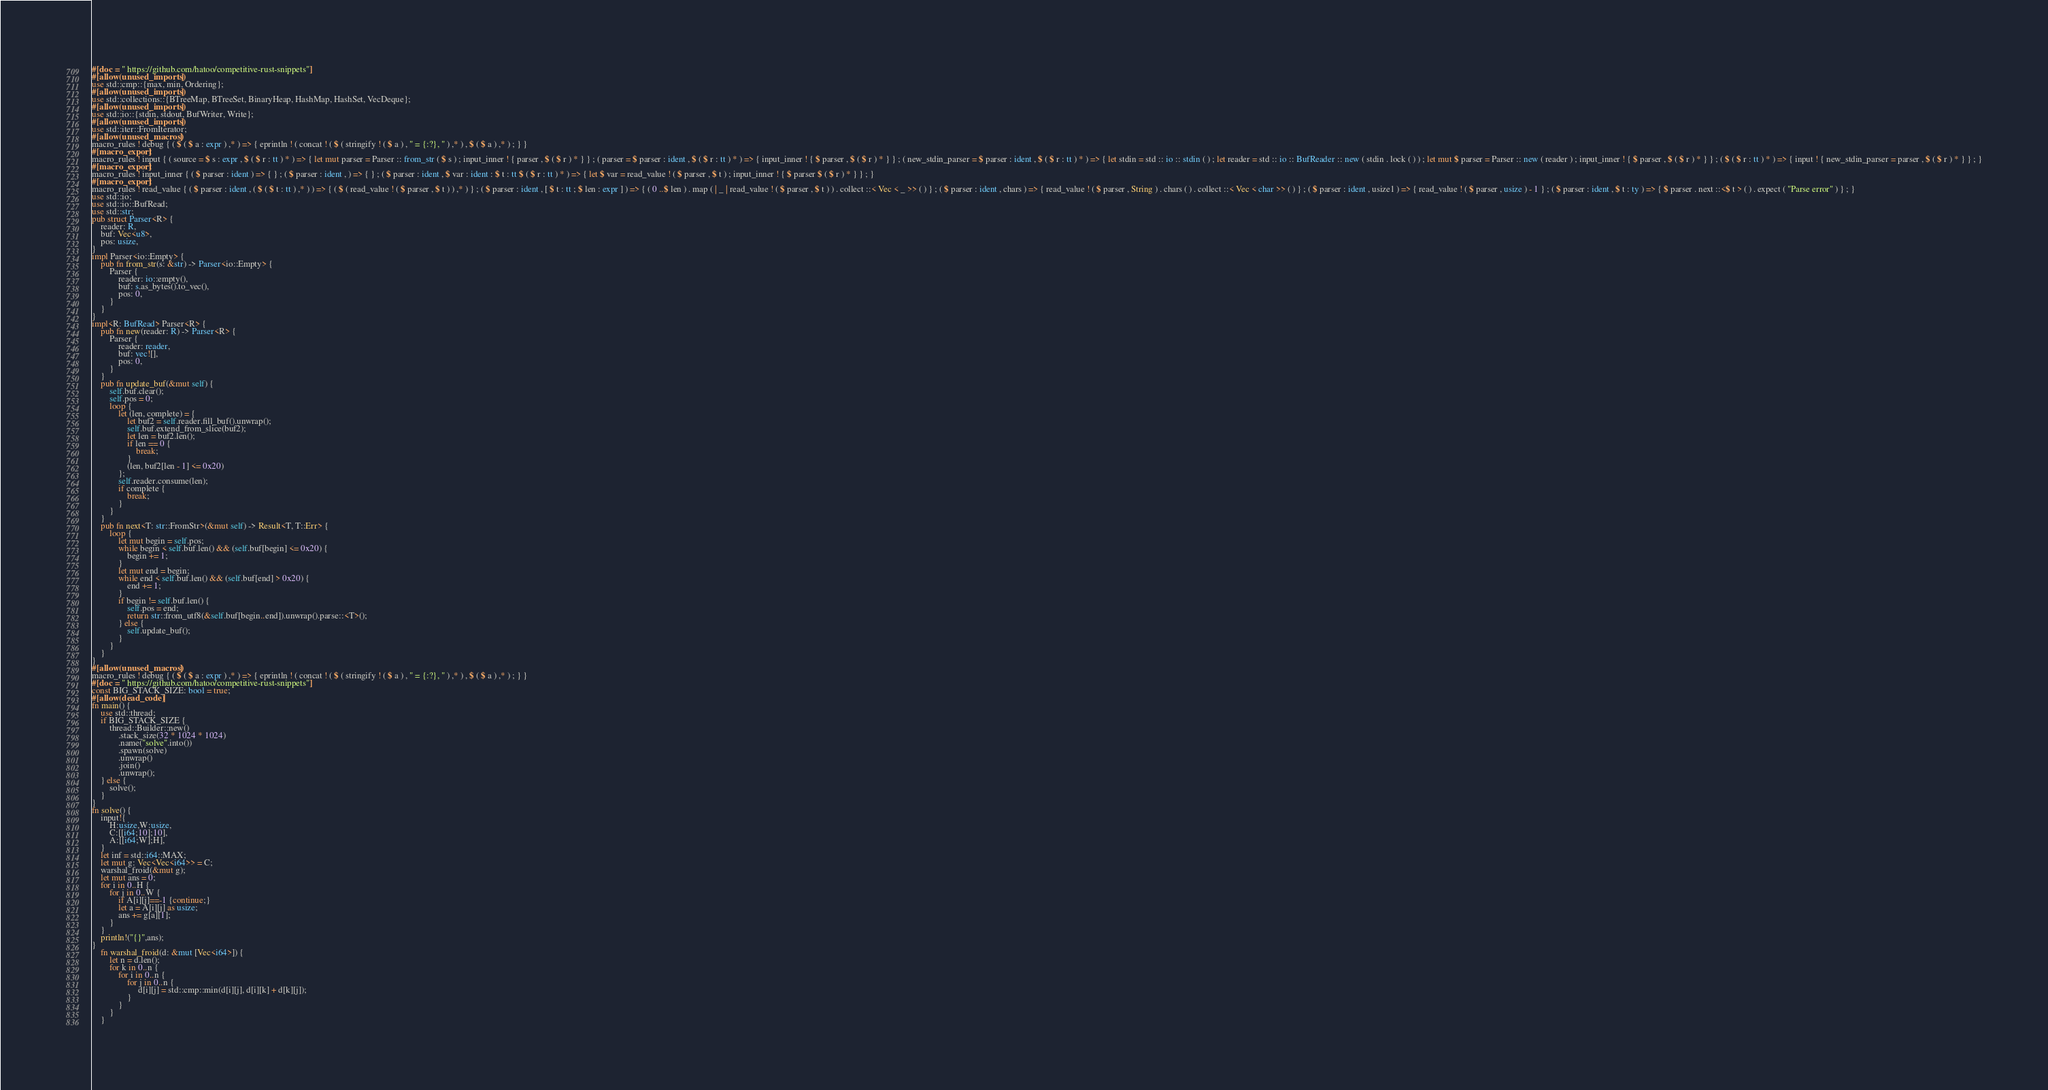<code> <loc_0><loc_0><loc_500><loc_500><_Rust_>#[doc = " https://github.com/hatoo/competitive-rust-snippets"]
#[allow(unused_imports)]
use std::cmp::{max, min, Ordering};
#[allow(unused_imports)]
use std::collections::{BTreeMap, BTreeSet, BinaryHeap, HashMap, HashSet, VecDeque};
#[allow(unused_imports)]
use std::io::{stdin, stdout, BufWriter, Write};
#[allow(unused_imports)]
use std::iter::FromIterator;
#[allow(unused_macros)]
macro_rules ! debug { ( $ ( $ a : expr ) ,* ) => { eprintln ! ( concat ! ( $ ( stringify ! ( $ a ) , " = {:?}, " ) ,* ) , $ ( $ a ) ,* ) ; } }
#[macro_export]
macro_rules ! input { ( source = $ s : expr , $ ( $ r : tt ) * ) => { let mut parser = Parser :: from_str ( $ s ) ; input_inner ! { parser , $ ( $ r ) * } } ; ( parser = $ parser : ident , $ ( $ r : tt ) * ) => { input_inner ! { $ parser , $ ( $ r ) * } } ; ( new_stdin_parser = $ parser : ident , $ ( $ r : tt ) * ) => { let stdin = std :: io :: stdin ( ) ; let reader = std :: io :: BufReader :: new ( stdin . lock ( ) ) ; let mut $ parser = Parser :: new ( reader ) ; input_inner ! { $ parser , $ ( $ r ) * } } ; ( $ ( $ r : tt ) * ) => { input ! { new_stdin_parser = parser , $ ( $ r ) * } } ; }
#[macro_export]
macro_rules ! input_inner { ( $ parser : ident ) => { } ; ( $ parser : ident , ) => { } ; ( $ parser : ident , $ var : ident : $ t : tt $ ( $ r : tt ) * ) => { let $ var = read_value ! ( $ parser , $ t ) ; input_inner ! { $ parser $ ( $ r ) * } } ; }
#[macro_export]
macro_rules ! read_value { ( $ parser : ident , ( $ ( $ t : tt ) ,* ) ) => { ( $ ( read_value ! ( $ parser , $ t ) ) ,* ) } ; ( $ parser : ident , [ $ t : tt ; $ len : expr ] ) => { ( 0 ..$ len ) . map ( | _ | read_value ! ( $ parser , $ t ) ) . collect ::< Vec < _ >> ( ) } ; ( $ parser : ident , chars ) => { read_value ! ( $ parser , String ) . chars ( ) . collect ::< Vec < char >> ( ) } ; ( $ parser : ident , usize1 ) => { read_value ! ( $ parser , usize ) - 1 } ; ( $ parser : ident , $ t : ty ) => { $ parser . next ::<$ t > ( ) . expect ( "Parse error" ) } ; }
use std::io;
use std::io::BufRead;
use std::str;
pub struct Parser<R> {
    reader: R,
    buf: Vec<u8>,
    pos: usize,
}
impl Parser<io::Empty> {
    pub fn from_str(s: &str) -> Parser<io::Empty> {
        Parser {
            reader: io::empty(),
            buf: s.as_bytes().to_vec(),
            pos: 0,
        }
    }
}
impl<R: BufRead> Parser<R> {
    pub fn new(reader: R) -> Parser<R> {
        Parser {
            reader: reader,
            buf: vec![],
            pos: 0,
        }
    }
    pub fn update_buf(&mut self) {
        self.buf.clear();
        self.pos = 0;
        loop {
            let (len, complete) = {
                let buf2 = self.reader.fill_buf().unwrap();
                self.buf.extend_from_slice(buf2);
                let len = buf2.len();
                if len == 0 {
                    break;
                }
                (len, buf2[len - 1] <= 0x20)
            };
            self.reader.consume(len);
            if complete {
                break;
            }
        }
    }
    pub fn next<T: str::FromStr>(&mut self) -> Result<T, T::Err> {
        loop {
            let mut begin = self.pos;
            while begin < self.buf.len() && (self.buf[begin] <= 0x20) {
                begin += 1;
            }
            let mut end = begin;
            while end < self.buf.len() && (self.buf[end] > 0x20) {
                end += 1;
            }
            if begin != self.buf.len() {
                self.pos = end;
                return str::from_utf8(&self.buf[begin..end]).unwrap().parse::<T>();
            } else {
                self.update_buf();
            }
        }
    }
}
#[allow(unused_macros)]
macro_rules ! debug { ( $ ( $ a : expr ) ,* ) => { eprintln ! ( concat ! ( $ ( stringify ! ( $ a ) , " = {:?}, " ) ,* ) , $ ( $ a ) ,* ) ; } }
#[doc = " https://github.com/hatoo/competitive-rust-snippets"]
const BIG_STACK_SIZE: bool = true;
#[allow(dead_code)]
fn main() {
    use std::thread;
    if BIG_STACK_SIZE {
        thread::Builder::new()
            .stack_size(32 * 1024 * 1024)
            .name("solve".into())
            .spawn(solve)
            .unwrap()
            .join()
            .unwrap();
    } else {
        solve();
    }
}
fn solve() {
    input!{
        H:usize,W:usize,
        C:[[i64;10];10],
        A:[[i64;W];H],
    }
    let inf = std::i64::MAX;
    let mut g: Vec<Vec<i64>> = C;
    warshal_froid(&mut g);
    let mut ans = 0;
    for i in 0..H {
        for j in 0..W {
            if A[i][j]==-1 {continue;}
            let a = A[i][j] as usize;
            ans += g[a][1];
        }
    }
    println!("{}",ans);
}
    fn warshal_froid(d: &mut [Vec<i64>]) {
        let n = d.len();
        for k in 0..n {
            for i in 0..n {
                for j in 0..n {
                     d[i][j] = std::cmp::min(d[i][j], d[i][k] + d[k][j]);
                }
            }
        }
    }</code> 